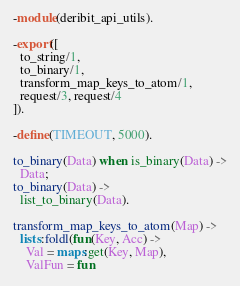Convert code to text. <code><loc_0><loc_0><loc_500><loc_500><_Erlang_>-module(deribit_api_utils).

-export([
  to_string/1,
  to_binary/1,
  transform_map_keys_to_atom/1,
  request/3, request/4
]).

-define(TIMEOUT, 5000).

to_binary(Data) when is_binary(Data) ->
  Data;
to_binary(Data) ->
  list_to_binary(Data).
  
transform_map_keys_to_atom(Map) ->
  lists:foldl(fun(Key, Acc) ->
    Val = maps:get(Key, Map),
    ValFun = fun </code> 